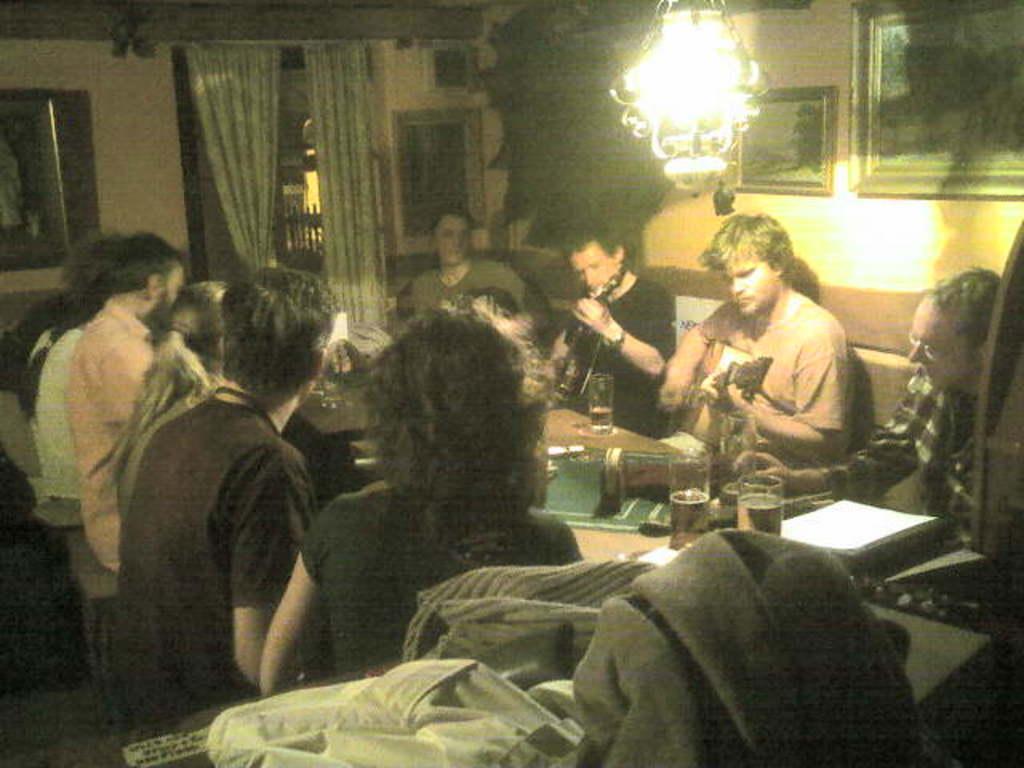How would you summarize this image in a sentence or two? In this image I can see few clothes and number of persons are sitting on chairs around the table. On the table I can see few glasses and few other objects. In the background I can see the wall, the curtain, few photo frames attached to the wall and a chandelier. 